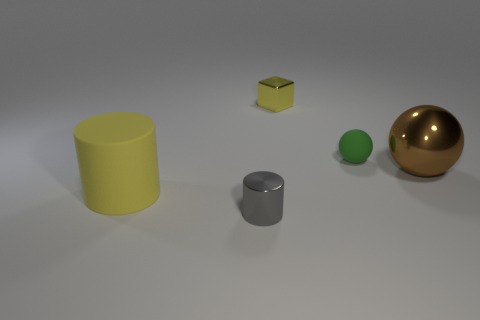Do the gray metallic object and the thing that is left of the tiny gray thing have the same shape?
Make the answer very short. Yes. What is the color of the big object to the right of the large object in front of the shiny object on the right side of the small yellow metallic cube?
Provide a succinct answer. Brown. What number of objects are either yellow things in front of the brown thing or things that are on the right side of the tiny metal block?
Provide a short and direct response. 3. How many other things are there of the same color as the tiny cylinder?
Your answer should be compact. 0. Is the shape of the tiny metal object that is in front of the big yellow matte cylinder the same as  the large matte thing?
Your answer should be compact. Yes. Is the number of tiny metallic things behind the gray metallic cylinder less than the number of large red matte cylinders?
Make the answer very short. No. Are there any small yellow things that have the same material as the tiny ball?
Your answer should be compact. No. There is a cube that is the same size as the green rubber object; what is it made of?
Your answer should be very brief. Metal. Is the number of large yellow rubber cylinders that are in front of the gray metal thing less than the number of green matte things on the right side of the matte sphere?
Give a very brief answer. No. What shape is the thing that is both in front of the big brown sphere and right of the big cylinder?
Offer a very short reply. Cylinder. 